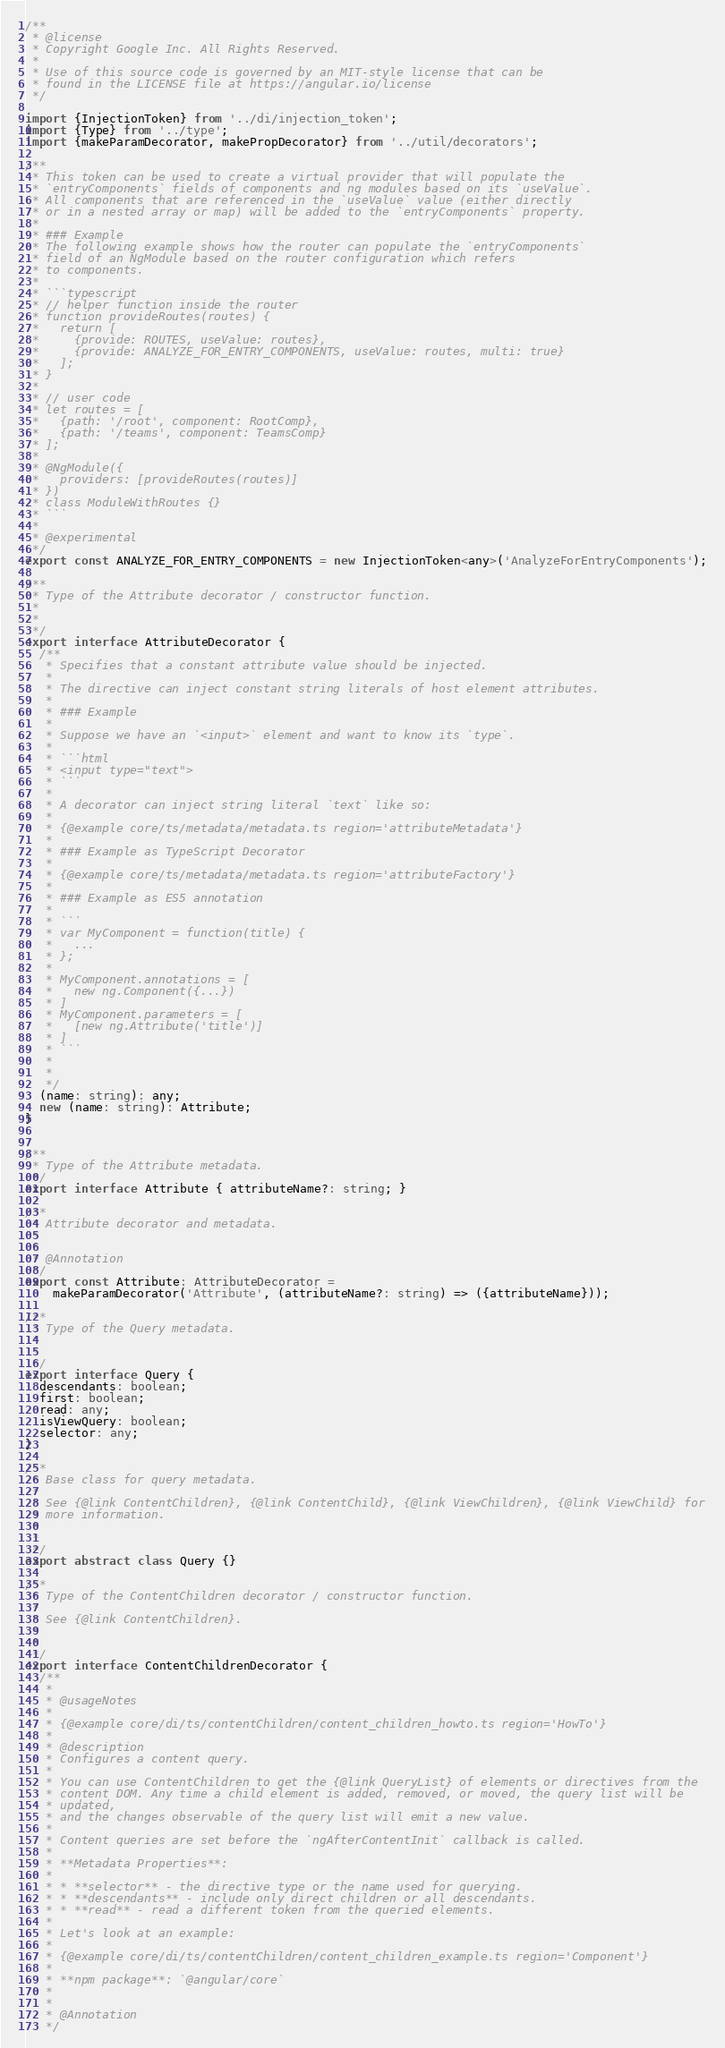<code> <loc_0><loc_0><loc_500><loc_500><_TypeScript_>/**
 * @license
 * Copyright Google Inc. All Rights Reserved.
 *
 * Use of this source code is governed by an MIT-style license that can be
 * found in the LICENSE file at https://angular.io/license
 */

import {InjectionToken} from '../di/injection_token';
import {Type} from '../type';
import {makeParamDecorator, makePropDecorator} from '../util/decorators';

/**
 * This token can be used to create a virtual provider that will populate the
 * `entryComponents` fields of components and ng modules based on its `useValue`.
 * All components that are referenced in the `useValue` value (either directly
 * or in a nested array or map) will be added to the `entryComponents` property.
 *
 * ### Example
 * The following example shows how the router can populate the `entryComponents`
 * field of an NgModule based on the router configuration which refers
 * to components.
 *
 * ```typescript
 * // helper function inside the router
 * function provideRoutes(routes) {
 *   return [
 *     {provide: ROUTES, useValue: routes},
 *     {provide: ANALYZE_FOR_ENTRY_COMPONENTS, useValue: routes, multi: true}
 *   ];
 * }
 *
 * // user code
 * let routes = [
 *   {path: '/root', component: RootComp},
 *   {path: '/teams', component: TeamsComp}
 * ];
 *
 * @NgModule({
 *   providers: [provideRoutes(routes)]
 * })
 * class ModuleWithRoutes {}
 * ```
 *
 * @experimental
 */
export const ANALYZE_FOR_ENTRY_COMPONENTS = new InjectionToken<any>('AnalyzeForEntryComponents');

/**
 * Type of the Attribute decorator / constructor function.
 *
 *
 */
export interface AttributeDecorator {
  /**
   * Specifies that a constant attribute value should be injected.
   *
   * The directive can inject constant string literals of host element attributes.
   *
   * ### Example
   *
   * Suppose we have an `<input>` element and want to know its `type`.
   *
   * ```html
   * <input type="text">
   * ```
   *
   * A decorator can inject string literal `text` like so:
   *
   * {@example core/ts/metadata/metadata.ts region='attributeMetadata'}
   *
   * ### Example as TypeScript Decorator
   *
   * {@example core/ts/metadata/metadata.ts region='attributeFactory'}
   *
   * ### Example as ES5 annotation
   *
   * ```
   * var MyComponent = function(title) {
   *   ...
   * };
   *
   * MyComponent.annotations = [
   *   new ng.Component({...})
   * ]
   * MyComponent.parameters = [
   *   [new ng.Attribute('title')]
   * ]
   * ```
   *
   *
   */
  (name: string): any;
  new (name: string): Attribute;
}


/**
 * Type of the Attribute metadata.
 */
export interface Attribute { attributeName?: string; }

/**
 * Attribute decorator and metadata.
 *
 *
 * @Annotation
 */
export const Attribute: AttributeDecorator =
    makeParamDecorator('Attribute', (attributeName?: string) => ({attributeName}));

/**
 * Type of the Query metadata.
 *
 *
 */
export interface Query {
  descendants: boolean;
  first: boolean;
  read: any;
  isViewQuery: boolean;
  selector: any;
}

/**
 * Base class for query metadata.
 *
 * See {@link ContentChildren}, {@link ContentChild}, {@link ViewChildren}, {@link ViewChild} for
 * more information.
 *
 *
 */
export abstract class Query {}

/**
 * Type of the ContentChildren decorator / constructor function.
 *
 * See {@link ContentChildren}.
 *
 *
 */
export interface ContentChildrenDecorator {
  /**
   *
   * @usageNotes
   *
   * {@example core/di/ts/contentChildren/content_children_howto.ts region='HowTo'}
   *
   * @description
   * Configures a content query.
   *
   * You can use ContentChildren to get the {@link QueryList} of elements or directives from the
   * content DOM. Any time a child element is added, removed, or moved, the query list will be
   * updated,
   * and the changes observable of the query list will emit a new value.
   *
   * Content queries are set before the `ngAfterContentInit` callback is called.
   *
   * **Metadata Properties**:
   *
   * * **selector** - the directive type or the name used for querying.
   * * **descendants** - include only direct children or all descendants.
   * * **read** - read a different token from the queried elements.
   *
   * Let's look at an example:
   *
   * {@example core/di/ts/contentChildren/content_children_example.ts region='Component'}
   *
   * **npm package**: `@angular/core`
   *
   *
   * @Annotation
   */</code> 